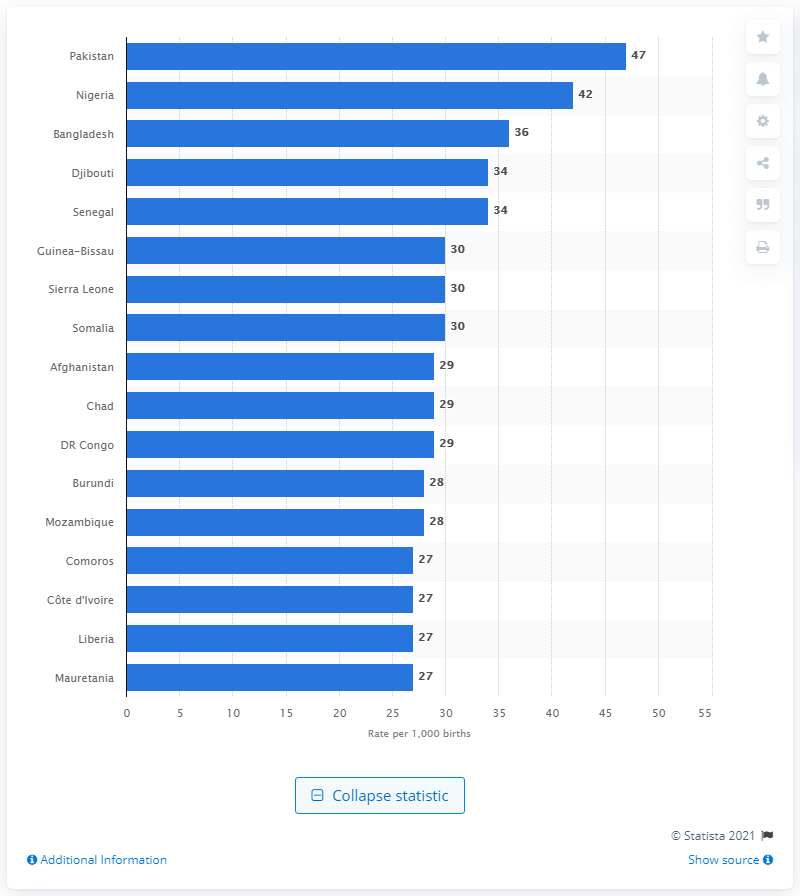Highlight a few significant elements in this photo. The country with the highest stillbirth rate worldwide in 2009 was Pakistan. 